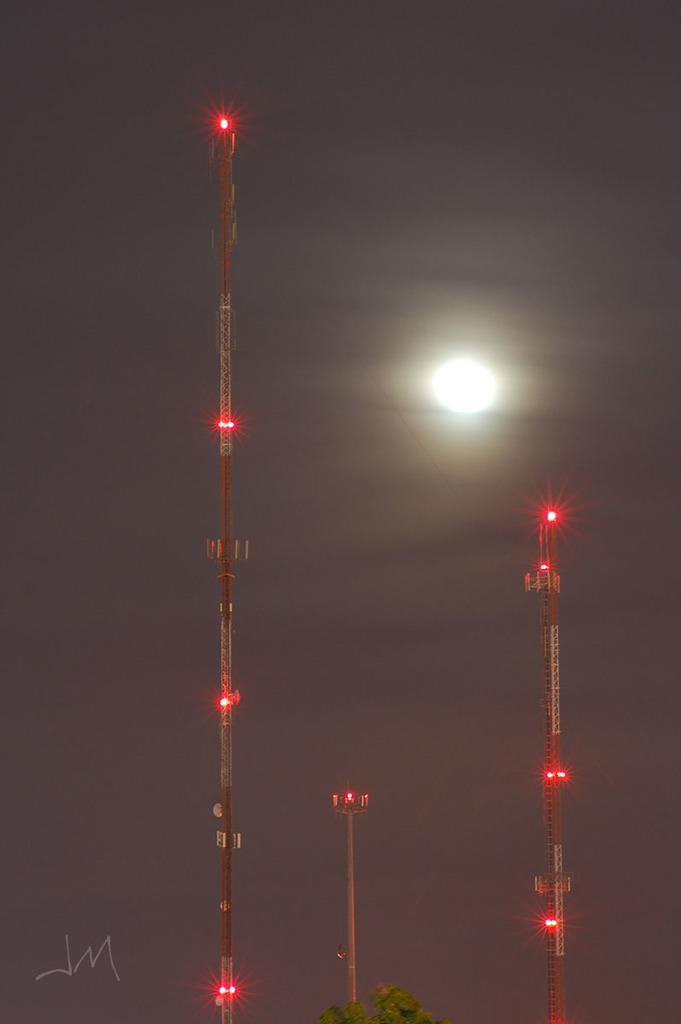In one or two sentences, can you explain what this image depicts? In this image we can see a tree, towers with lights and the sky with the moon in the black background. 